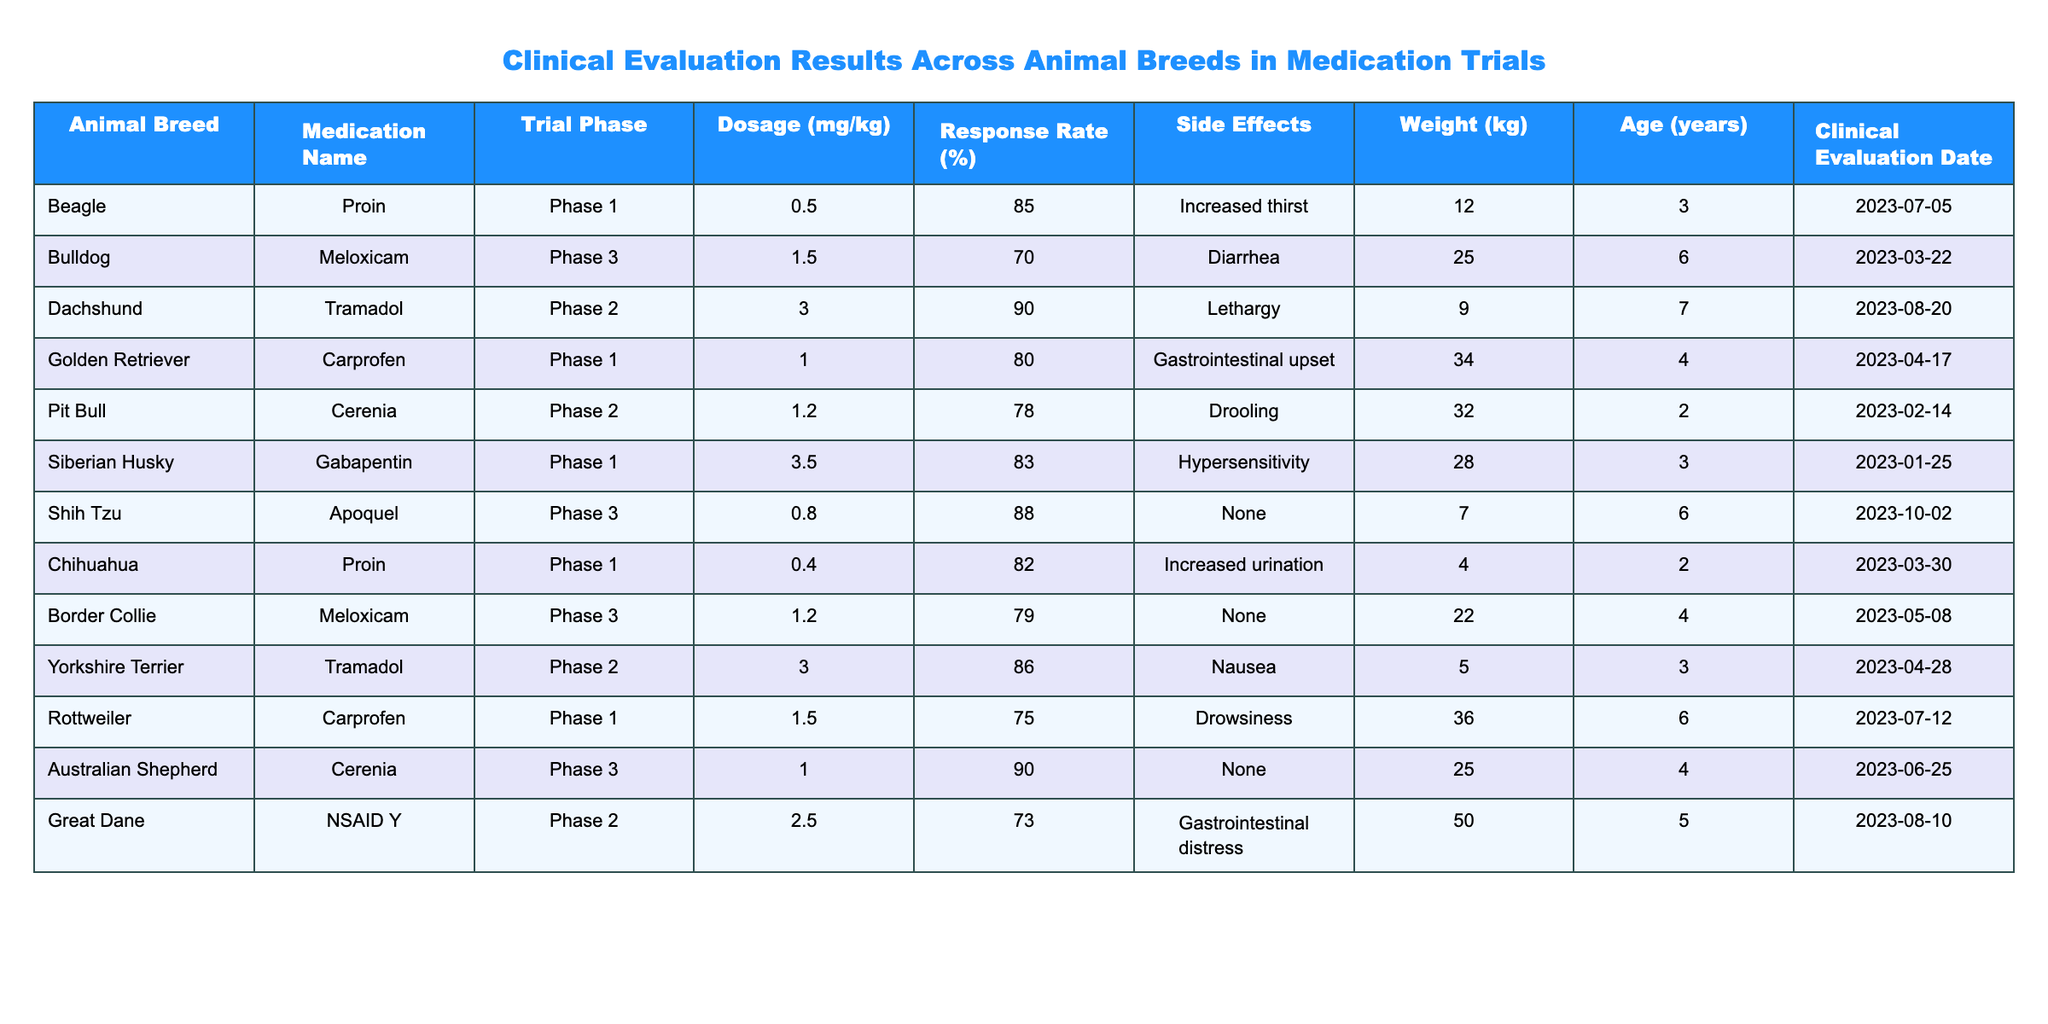What is the response rate for the Beagle breed treated with Proin? The table shows that the Beagle breed has a response rate of 85% when treated with Proin.
Answer: 85% Which medication had the highest response rate and what was that rate? The Dachshund received Tramadol with a response rate of 90%, which is the highest in the table.
Answer: 90% Did any animal breed experience side effects labeled as "None"? Yes, both the Shih Tzu and the Australian Shepherd had "None" listed as side effects in their trials.
Answer: Yes What is the average dosage across all medications in mg/kg? The dosages are: 0.5, 1.5, 3.0, 1.0, 1.2, 3.5, 0.8, 0.4, 1.2, 3.0, 1.5, 1.0, and 2.5, summing them gives 18.3. Dividing by 13 (the total number of entries) results in an average of approximately 1.41 mg/kg.
Answer: 1.41 mg/kg Are there any breeds with a response rate below 75%? Yes, the Rottweiler has a response rate of 75%, and the Great Dane has a response rate of 73%, both of which are below 75%.
Answer: Yes What is the age of the oldest animal in the trials, and which breed is it? The Rottweiler is the oldest at 6 years. The age values in the table are 3, 6, 7, 4, 2, 3, 6, 2, 4, 3, 6, 4, and 5, making Rottweiler the oldest.
Answer: 6 years (Rottweiler) If you sum the weights of all the breeds, what is the total weight in kg? Adding the weights: 12 + 25 + 9 + 34 + 32 + 28 + 7 + 4 + 22 + 5 + 36 + 25 + 50 gives a total weight of  336 kg.
Answer: 336 kg Which breed had the side effect of "Increased urination" and what medication was used? The Chihuahua experienced "Increased urination" while being treated with Proin. This information is directly taken from the respective row in the table.
Answer: Chihuahua, Proin Is there a breed that had a dosage higher than 3.0 mg/kg? If so, which breeds? Yes, the Rottweiler (1.5), the Great Dane (2.5), and the Dachshund (3.0) had dosages higher than 3.0, with only the Dachshund exactly at 3.0 and the pirate bull at 1.2.
Answer: Yes What is the total number of breeds in the Phase 3 trial? The breeds in Phase 3 are Bulldog, Shih Tzu, Border Collie, and Australian Shepherd, totaling 4 breeds.
Answer: 4 